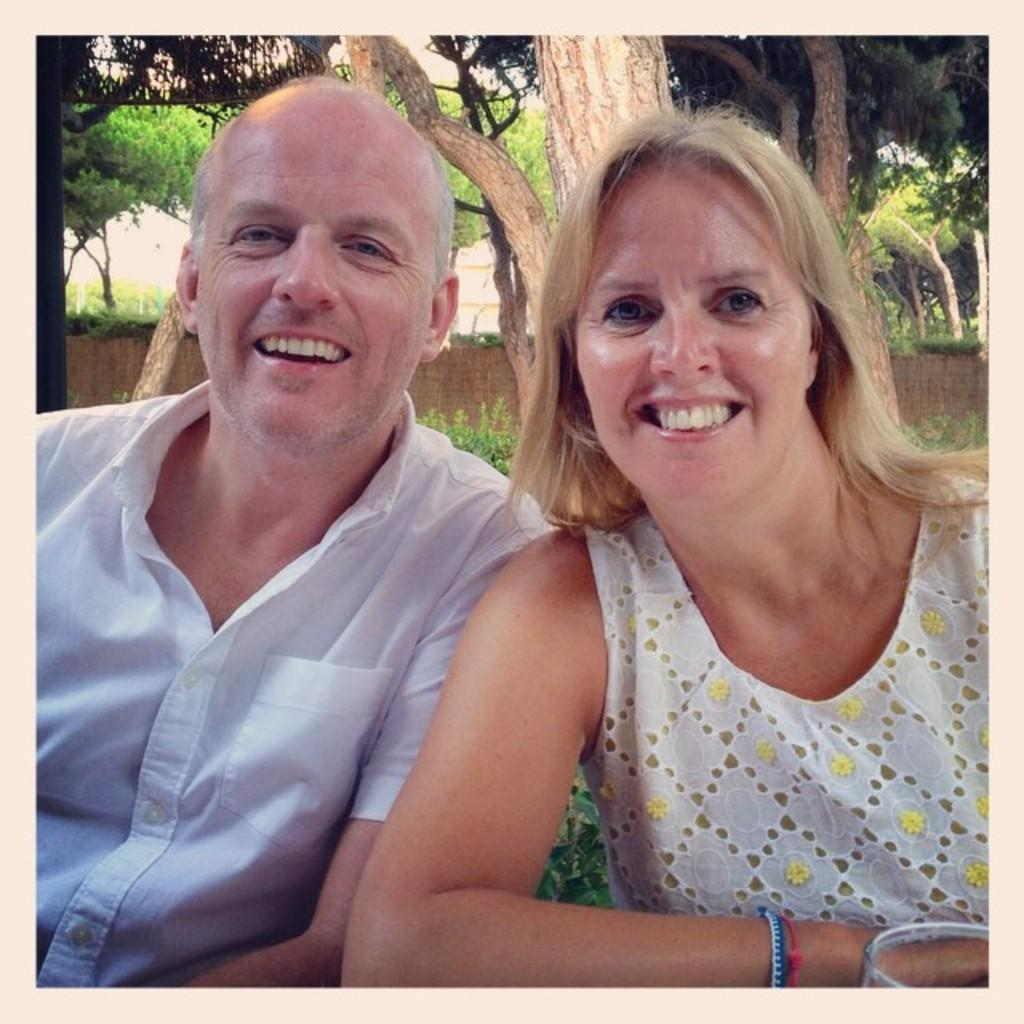How many people are in the image? There are two people in the image. What colors are the dresses of the people in the image? One person is wearing a white dress, and the other person is wearing a yellow dress. What can be seen in the background of the image? There are many trees visible in the background, and there is also a wall. Where is the throne located in the image? There is no throne present in the image. What are the people in the image talking about? The image does not provide any information about what the people might be talking about. 